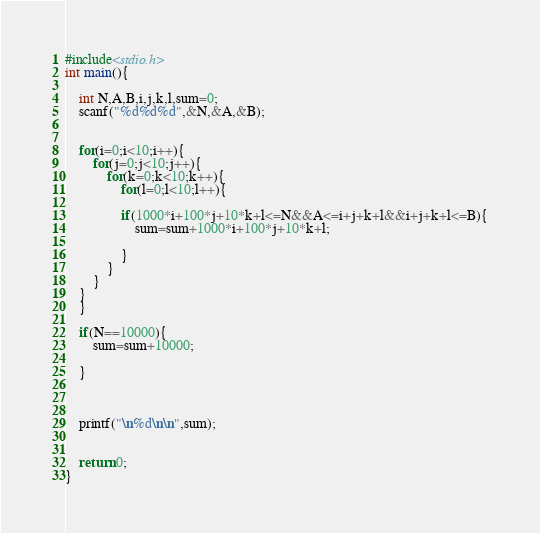Convert code to text. <code><loc_0><loc_0><loc_500><loc_500><_C_>#include<stdio.h>
int main(){
	
	int N,A,B,i,j,k,l,sum=0;
	scanf("%d%d%d",&N,&A,&B);
	
	
	for(i=0;i<10;i++){
		for(j=0;j<10;j++){
			for(k=0;k<10;k++){
				for(l=0;l<10;l++){
				
				if(1000*i+100*j+10*k+l<=N&&A<=i+j+k+l&&i+j+k+l<=B){
					sum=sum+1000*i+100*j+10*k+l;
				
				}
			}
		}
	}
	}
	
	if(N==10000){
		sum=sum+10000;
		
	}
	
	
	
	printf("\n%d\n\n",sum);
	
	
	return 0;
}</code> 